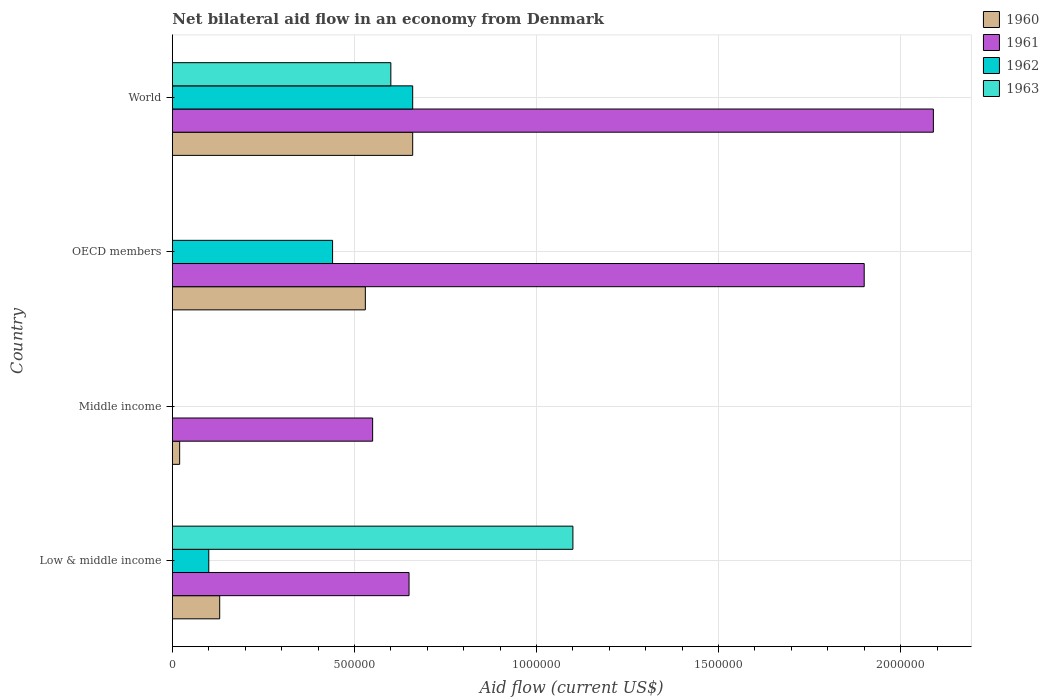How many different coloured bars are there?
Give a very brief answer. 4. How many groups of bars are there?
Give a very brief answer. 4. What is the label of the 1st group of bars from the top?
Make the answer very short. World. Across all countries, what is the minimum net bilateral aid flow in 1963?
Offer a terse response. 0. In which country was the net bilateral aid flow in 1962 maximum?
Give a very brief answer. World. What is the total net bilateral aid flow in 1960 in the graph?
Keep it short and to the point. 1.34e+06. What is the difference between the net bilateral aid flow in 1962 in Low & middle income and that in World?
Make the answer very short. -5.60e+05. What is the difference between the net bilateral aid flow in 1963 in World and the net bilateral aid flow in 1961 in Low & middle income?
Offer a very short reply. -5.00e+04. What is the average net bilateral aid flow in 1961 per country?
Keep it short and to the point. 1.30e+06. What is the difference between the net bilateral aid flow in 1963 and net bilateral aid flow in 1962 in Low & middle income?
Ensure brevity in your answer.  1.00e+06. In how many countries, is the net bilateral aid flow in 1960 greater than 1900000 US$?
Offer a terse response. 0. What is the ratio of the net bilateral aid flow in 1961 in Low & middle income to that in Middle income?
Give a very brief answer. 1.18. Is the net bilateral aid flow in 1960 in Middle income less than that in OECD members?
Keep it short and to the point. Yes. Is the difference between the net bilateral aid flow in 1963 in Low & middle income and World greater than the difference between the net bilateral aid flow in 1962 in Low & middle income and World?
Your answer should be very brief. Yes. What is the difference between the highest and the lowest net bilateral aid flow in 1962?
Make the answer very short. 6.60e+05. Is it the case that in every country, the sum of the net bilateral aid flow in 1960 and net bilateral aid flow in 1962 is greater than the sum of net bilateral aid flow in 1963 and net bilateral aid flow in 1961?
Your answer should be very brief. No. How many bars are there?
Offer a very short reply. 13. Are all the bars in the graph horizontal?
Your response must be concise. Yes. How many countries are there in the graph?
Give a very brief answer. 4. How are the legend labels stacked?
Your answer should be compact. Vertical. What is the title of the graph?
Ensure brevity in your answer.  Net bilateral aid flow in an economy from Denmark. What is the label or title of the X-axis?
Give a very brief answer. Aid flow (current US$). What is the label or title of the Y-axis?
Make the answer very short. Country. What is the Aid flow (current US$) of 1961 in Low & middle income?
Your answer should be very brief. 6.50e+05. What is the Aid flow (current US$) in 1962 in Low & middle income?
Give a very brief answer. 1.00e+05. What is the Aid flow (current US$) of 1963 in Low & middle income?
Give a very brief answer. 1.10e+06. What is the Aid flow (current US$) of 1961 in Middle income?
Provide a succinct answer. 5.50e+05. What is the Aid flow (current US$) of 1962 in Middle income?
Provide a short and direct response. 0. What is the Aid flow (current US$) in 1960 in OECD members?
Your answer should be very brief. 5.30e+05. What is the Aid flow (current US$) of 1961 in OECD members?
Your response must be concise. 1.90e+06. What is the Aid flow (current US$) in 1962 in OECD members?
Make the answer very short. 4.40e+05. What is the Aid flow (current US$) of 1963 in OECD members?
Your answer should be compact. 0. What is the Aid flow (current US$) in 1960 in World?
Your answer should be very brief. 6.60e+05. What is the Aid flow (current US$) of 1961 in World?
Provide a short and direct response. 2.09e+06. Across all countries, what is the maximum Aid flow (current US$) in 1961?
Your answer should be very brief. 2.09e+06. Across all countries, what is the maximum Aid flow (current US$) of 1963?
Ensure brevity in your answer.  1.10e+06. Across all countries, what is the minimum Aid flow (current US$) of 1960?
Provide a short and direct response. 2.00e+04. Across all countries, what is the minimum Aid flow (current US$) in 1961?
Offer a terse response. 5.50e+05. What is the total Aid flow (current US$) in 1960 in the graph?
Your answer should be compact. 1.34e+06. What is the total Aid flow (current US$) of 1961 in the graph?
Keep it short and to the point. 5.19e+06. What is the total Aid flow (current US$) in 1962 in the graph?
Provide a succinct answer. 1.20e+06. What is the total Aid flow (current US$) in 1963 in the graph?
Make the answer very short. 1.70e+06. What is the difference between the Aid flow (current US$) in 1960 in Low & middle income and that in Middle income?
Offer a very short reply. 1.10e+05. What is the difference between the Aid flow (current US$) in 1961 in Low & middle income and that in Middle income?
Your answer should be compact. 1.00e+05. What is the difference between the Aid flow (current US$) in 1960 in Low & middle income and that in OECD members?
Offer a terse response. -4.00e+05. What is the difference between the Aid flow (current US$) of 1961 in Low & middle income and that in OECD members?
Make the answer very short. -1.25e+06. What is the difference between the Aid flow (current US$) in 1962 in Low & middle income and that in OECD members?
Keep it short and to the point. -3.40e+05. What is the difference between the Aid flow (current US$) of 1960 in Low & middle income and that in World?
Provide a succinct answer. -5.30e+05. What is the difference between the Aid flow (current US$) in 1961 in Low & middle income and that in World?
Give a very brief answer. -1.44e+06. What is the difference between the Aid flow (current US$) in 1962 in Low & middle income and that in World?
Offer a terse response. -5.60e+05. What is the difference between the Aid flow (current US$) of 1960 in Middle income and that in OECD members?
Your answer should be very brief. -5.10e+05. What is the difference between the Aid flow (current US$) of 1961 in Middle income and that in OECD members?
Your answer should be compact. -1.35e+06. What is the difference between the Aid flow (current US$) in 1960 in Middle income and that in World?
Provide a succinct answer. -6.40e+05. What is the difference between the Aid flow (current US$) of 1961 in Middle income and that in World?
Keep it short and to the point. -1.54e+06. What is the difference between the Aid flow (current US$) in 1960 in OECD members and that in World?
Offer a terse response. -1.30e+05. What is the difference between the Aid flow (current US$) in 1961 in OECD members and that in World?
Keep it short and to the point. -1.90e+05. What is the difference between the Aid flow (current US$) in 1962 in OECD members and that in World?
Make the answer very short. -2.20e+05. What is the difference between the Aid flow (current US$) in 1960 in Low & middle income and the Aid flow (current US$) in 1961 in Middle income?
Ensure brevity in your answer.  -4.20e+05. What is the difference between the Aid flow (current US$) of 1960 in Low & middle income and the Aid flow (current US$) of 1961 in OECD members?
Provide a short and direct response. -1.77e+06. What is the difference between the Aid flow (current US$) in 1960 in Low & middle income and the Aid flow (current US$) in 1962 in OECD members?
Ensure brevity in your answer.  -3.10e+05. What is the difference between the Aid flow (current US$) of 1961 in Low & middle income and the Aid flow (current US$) of 1962 in OECD members?
Provide a short and direct response. 2.10e+05. What is the difference between the Aid flow (current US$) in 1960 in Low & middle income and the Aid flow (current US$) in 1961 in World?
Keep it short and to the point. -1.96e+06. What is the difference between the Aid flow (current US$) of 1960 in Low & middle income and the Aid flow (current US$) of 1962 in World?
Your answer should be very brief. -5.30e+05. What is the difference between the Aid flow (current US$) of 1960 in Low & middle income and the Aid flow (current US$) of 1963 in World?
Your answer should be compact. -4.70e+05. What is the difference between the Aid flow (current US$) of 1962 in Low & middle income and the Aid flow (current US$) of 1963 in World?
Your answer should be very brief. -5.00e+05. What is the difference between the Aid flow (current US$) of 1960 in Middle income and the Aid flow (current US$) of 1961 in OECD members?
Your answer should be very brief. -1.88e+06. What is the difference between the Aid flow (current US$) in 1960 in Middle income and the Aid flow (current US$) in 1962 in OECD members?
Keep it short and to the point. -4.20e+05. What is the difference between the Aid flow (current US$) of 1960 in Middle income and the Aid flow (current US$) of 1961 in World?
Your response must be concise. -2.07e+06. What is the difference between the Aid flow (current US$) in 1960 in Middle income and the Aid flow (current US$) in 1962 in World?
Your answer should be very brief. -6.40e+05. What is the difference between the Aid flow (current US$) of 1960 in Middle income and the Aid flow (current US$) of 1963 in World?
Offer a very short reply. -5.80e+05. What is the difference between the Aid flow (current US$) of 1961 in Middle income and the Aid flow (current US$) of 1962 in World?
Offer a terse response. -1.10e+05. What is the difference between the Aid flow (current US$) of 1960 in OECD members and the Aid flow (current US$) of 1961 in World?
Your answer should be very brief. -1.56e+06. What is the difference between the Aid flow (current US$) of 1961 in OECD members and the Aid flow (current US$) of 1962 in World?
Make the answer very short. 1.24e+06. What is the difference between the Aid flow (current US$) in 1961 in OECD members and the Aid flow (current US$) in 1963 in World?
Make the answer very short. 1.30e+06. What is the average Aid flow (current US$) in 1960 per country?
Your answer should be compact. 3.35e+05. What is the average Aid flow (current US$) in 1961 per country?
Your answer should be very brief. 1.30e+06. What is the average Aid flow (current US$) of 1963 per country?
Your response must be concise. 4.25e+05. What is the difference between the Aid flow (current US$) of 1960 and Aid flow (current US$) of 1961 in Low & middle income?
Your response must be concise. -5.20e+05. What is the difference between the Aid flow (current US$) of 1960 and Aid flow (current US$) of 1963 in Low & middle income?
Offer a very short reply. -9.70e+05. What is the difference between the Aid flow (current US$) in 1961 and Aid flow (current US$) in 1962 in Low & middle income?
Give a very brief answer. 5.50e+05. What is the difference between the Aid flow (current US$) in 1961 and Aid flow (current US$) in 1963 in Low & middle income?
Provide a succinct answer. -4.50e+05. What is the difference between the Aid flow (current US$) in 1960 and Aid flow (current US$) in 1961 in Middle income?
Ensure brevity in your answer.  -5.30e+05. What is the difference between the Aid flow (current US$) of 1960 and Aid flow (current US$) of 1961 in OECD members?
Provide a succinct answer. -1.37e+06. What is the difference between the Aid flow (current US$) in 1961 and Aid flow (current US$) in 1962 in OECD members?
Your response must be concise. 1.46e+06. What is the difference between the Aid flow (current US$) of 1960 and Aid flow (current US$) of 1961 in World?
Provide a short and direct response. -1.43e+06. What is the difference between the Aid flow (current US$) of 1961 and Aid flow (current US$) of 1962 in World?
Your answer should be compact. 1.43e+06. What is the difference between the Aid flow (current US$) in 1961 and Aid flow (current US$) in 1963 in World?
Your response must be concise. 1.49e+06. What is the difference between the Aid flow (current US$) of 1962 and Aid flow (current US$) of 1963 in World?
Provide a succinct answer. 6.00e+04. What is the ratio of the Aid flow (current US$) of 1960 in Low & middle income to that in Middle income?
Provide a succinct answer. 6.5. What is the ratio of the Aid flow (current US$) of 1961 in Low & middle income to that in Middle income?
Offer a terse response. 1.18. What is the ratio of the Aid flow (current US$) in 1960 in Low & middle income to that in OECD members?
Your answer should be compact. 0.25. What is the ratio of the Aid flow (current US$) in 1961 in Low & middle income to that in OECD members?
Make the answer very short. 0.34. What is the ratio of the Aid flow (current US$) in 1962 in Low & middle income to that in OECD members?
Offer a very short reply. 0.23. What is the ratio of the Aid flow (current US$) of 1960 in Low & middle income to that in World?
Your answer should be compact. 0.2. What is the ratio of the Aid flow (current US$) of 1961 in Low & middle income to that in World?
Ensure brevity in your answer.  0.31. What is the ratio of the Aid flow (current US$) of 1962 in Low & middle income to that in World?
Provide a succinct answer. 0.15. What is the ratio of the Aid flow (current US$) in 1963 in Low & middle income to that in World?
Provide a succinct answer. 1.83. What is the ratio of the Aid flow (current US$) of 1960 in Middle income to that in OECD members?
Ensure brevity in your answer.  0.04. What is the ratio of the Aid flow (current US$) in 1961 in Middle income to that in OECD members?
Provide a short and direct response. 0.29. What is the ratio of the Aid flow (current US$) in 1960 in Middle income to that in World?
Your response must be concise. 0.03. What is the ratio of the Aid flow (current US$) in 1961 in Middle income to that in World?
Keep it short and to the point. 0.26. What is the ratio of the Aid flow (current US$) in 1960 in OECD members to that in World?
Give a very brief answer. 0.8. What is the ratio of the Aid flow (current US$) of 1961 in OECD members to that in World?
Provide a succinct answer. 0.91. What is the difference between the highest and the second highest Aid flow (current US$) in 1960?
Offer a terse response. 1.30e+05. What is the difference between the highest and the second highest Aid flow (current US$) in 1961?
Make the answer very short. 1.90e+05. What is the difference between the highest and the lowest Aid flow (current US$) in 1960?
Provide a short and direct response. 6.40e+05. What is the difference between the highest and the lowest Aid flow (current US$) in 1961?
Keep it short and to the point. 1.54e+06. What is the difference between the highest and the lowest Aid flow (current US$) in 1962?
Your response must be concise. 6.60e+05. What is the difference between the highest and the lowest Aid flow (current US$) of 1963?
Give a very brief answer. 1.10e+06. 